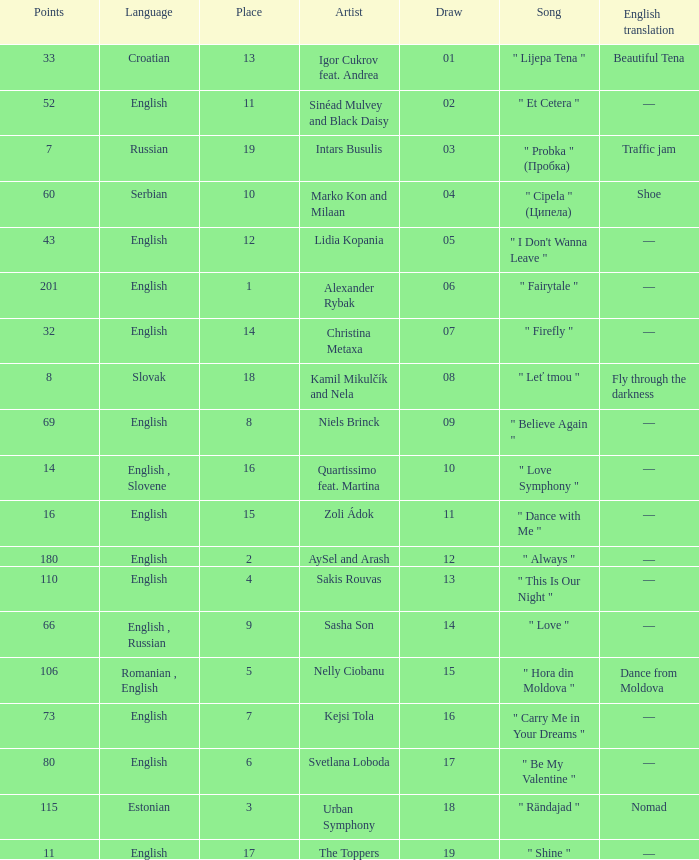What is the average Points when the artist is kamil mikulčík and nela, and the Place is larger than 18? None. 